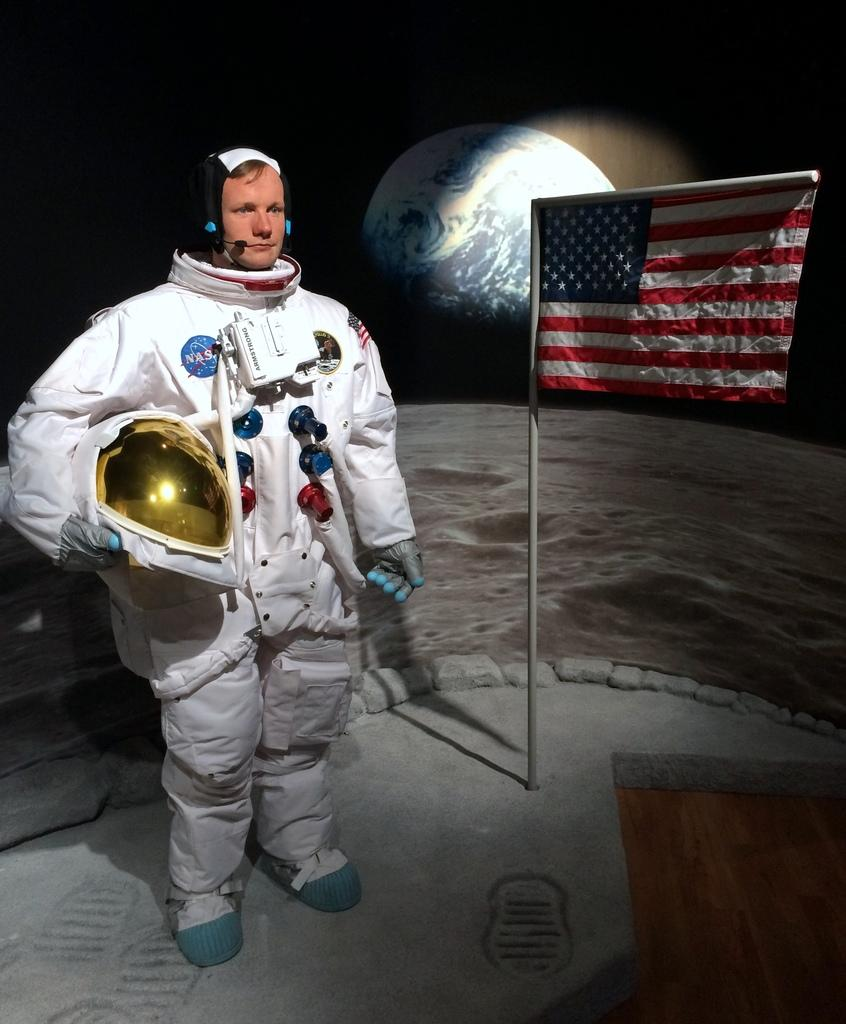What is the person in the image wearing? The person in the image is wearing a space suit. What is the person holding in the image? The person is holding a helmet. What can be seen attached to the pole in the image? There is a flag attached to the pole in the image. What is the color of the background in the image? The background of the image is dark. What celestial body is visible in the image? The Earth is visible in the image. How many births are taking place in the image? There are no births taking place in the image. What type of growth can be observed on the table in the image? There is no table present in the image, and therefore no growth can be observed on it. 